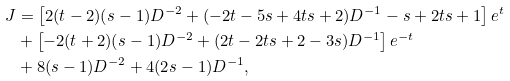<formula> <loc_0><loc_0><loc_500><loc_500>J & = \left [ 2 ( t - 2 ) ( s - 1 ) D ^ { - 2 } + ( - 2 t - 5 s + 4 t s + 2 ) D ^ { - 1 } - s + 2 t s + 1 \right ] e ^ { t } \\ & + \left [ - 2 ( t + 2 ) ( s - 1 ) D ^ { - 2 } + ( 2 t - 2 t s + 2 - 3 s ) D ^ { - 1 } \right ] e ^ { - t } \\ & + 8 ( s - 1 ) D ^ { - 2 } + 4 ( 2 s - 1 ) D ^ { - 1 } ,</formula> 